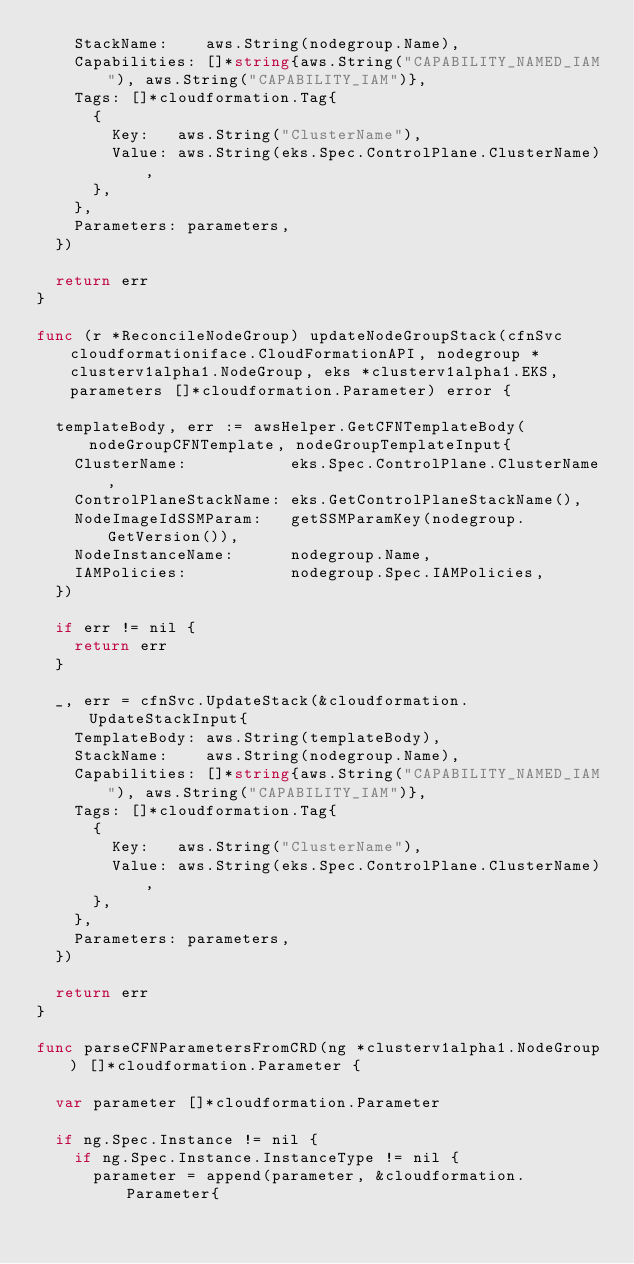<code> <loc_0><loc_0><loc_500><loc_500><_Go_>		StackName:    aws.String(nodegroup.Name),
		Capabilities: []*string{aws.String("CAPABILITY_NAMED_IAM"), aws.String("CAPABILITY_IAM")},
		Tags: []*cloudformation.Tag{
			{
				Key:   aws.String("ClusterName"),
				Value: aws.String(eks.Spec.ControlPlane.ClusterName),
			},
		},
		Parameters: parameters,
	})

	return err
}

func (r *ReconcileNodeGroup) updateNodeGroupStack(cfnSvc cloudformationiface.CloudFormationAPI, nodegroup *clusterv1alpha1.NodeGroup, eks *clusterv1alpha1.EKS, parameters []*cloudformation.Parameter) error {

	templateBody, err := awsHelper.GetCFNTemplateBody(nodeGroupCFNTemplate, nodeGroupTemplateInput{
		ClusterName:           eks.Spec.ControlPlane.ClusterName,
		ControlPlaneStackName: eks.GetControlPlaneStackName(),
		NodeImageIdSSMParam:   getSSMParamKey(nodegroup.GetVersion()),
		NodeInstanceName:      nodegroup.Name,
		IAMPolicies:           nodegroup.Spec.IAMPolicies,
	})

	if err != nil {
		return err
	}

	_, err = cfnSvc.UpdateStack(&cloudformation.UpdateStackInput{
		TemplateBody: aws.String(templateBody),
		StackName:    aws.String(nodegroup.Name),
		Capabilities: []*string{aws.String("CAPABILITY_NAMED_IAM"), aws.String("CAPABILITY_IAM")},
		Tags: []*cloudformation.Tag{
			{
				Key:   aws.String("ClusterName"),
				Value: aws.String(eks.Spec.ControlPlane.ClusterName),
			},
		},
		Parameters: parameters,
	})

	return err
}

func parseCFNParametersFromCRD(ng *clusterv1alpha1.NodeGroup) []*cloudformation.Parameter {

	var parameter []*cloudformation.Parameter

	if ng.Spec.Instance != nil {
		if ng.Spec.Instance.InstanceType != nil {
			parameter = append(parameter, &cloudformation.Parameter{</code> 